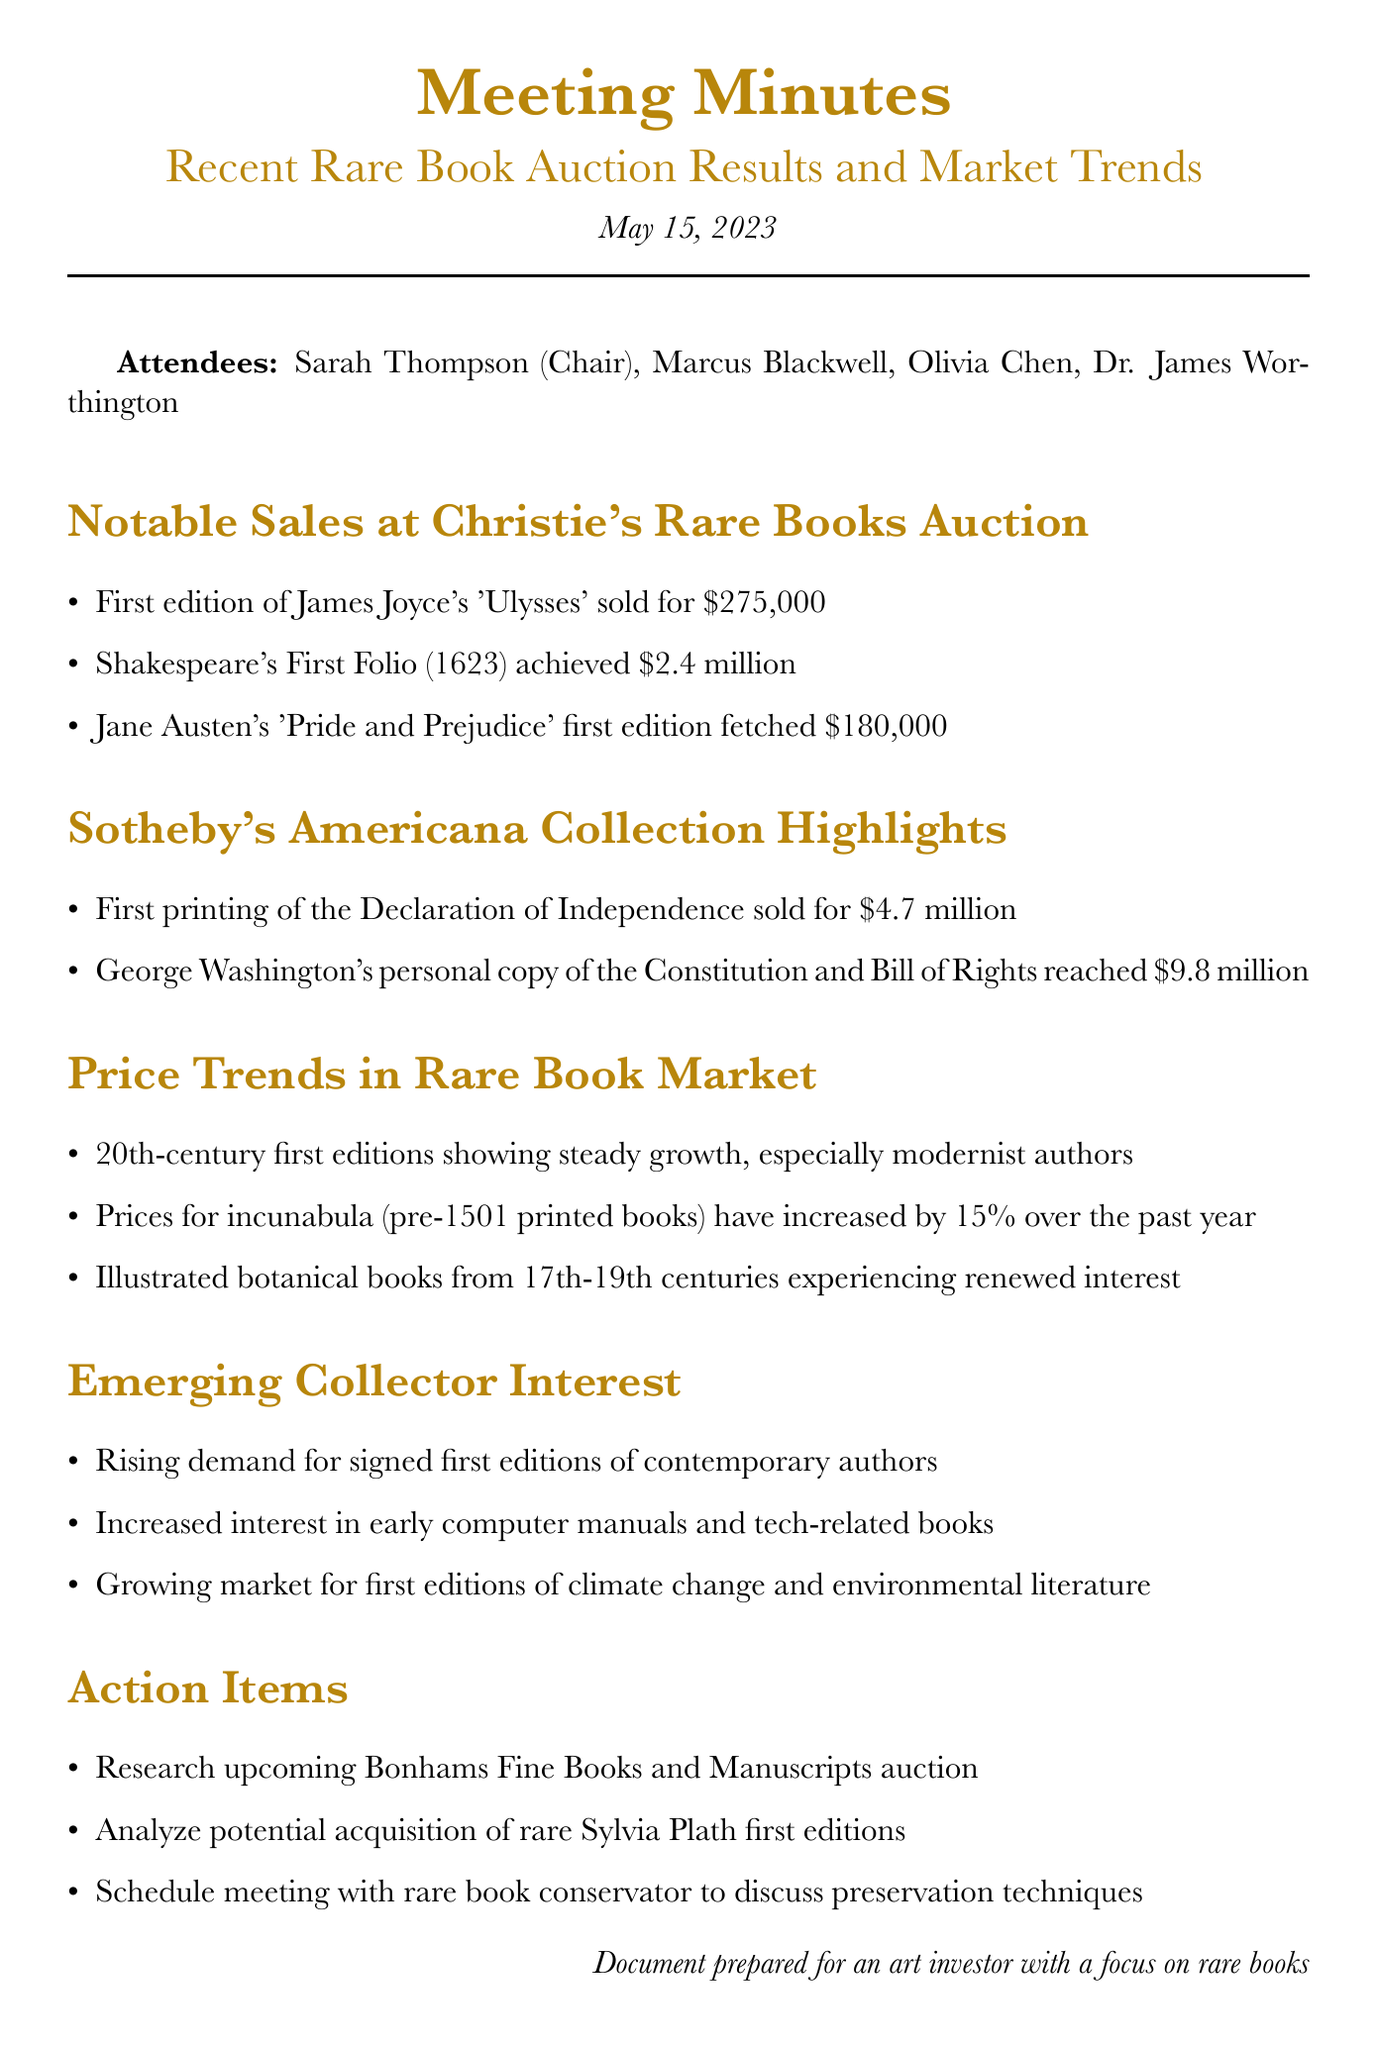What was the date of the meeting? The date of the meeting is provided at the top of the document, which is May 15, 2023.
Answer: May 15, 2023 Who chaired the meeting? The chair of the meeting is stated in the attendees section, which is Sarah Thompson.
Answer: Sarah Thompson What was the price of Shakespeare's First Folio? The price for Shakespeare's First Folio is detailed in the notable sales section of the document, which is $2.4 million.
Answer: $2.4 million Which category of rare books saw a 15% price increase over the past year? The document mentions a specific category experiencing price growth in the price trends section, which is incunabula.
Answer: incunabula What is one action item mentioned in the document? The action items section lists specific tasks to be addressed, one of which is to research upcoming Bonhams Fine Books and Manuscripts auction.
Answer: Research upcoming Bonhams Fine Books and Manuscripts auction What notable sale achieved $9.8 million? The document gives specific details about notable sales, including George Washington's personal copy of the Constitution and Bill of Rights, which reached $9.8 million.
Answer: George Washington's personal copy of the Constitution and Bill of Rights What emerging trend is noted in collector interest? The document discusses rising demand in emerging collector interests, specifically for signed first editions of contemporary authors.
Answer: Signed first editions of contemporary authors Which auction house featured the sale of the first printing of the Declaration of Independence? The notable sales list identifies the auction house for this item, which is Sotheby's.
Answer: Sotheby's 